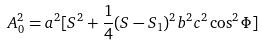<formula> <loc_0><loc_0><loc_500><loc_500>A _ { 0 } ^ { 2 } = a ^ { 2 } [ S ^ { 2 } + \frac { 1 } { 4 } ( S - S _ { 1 } ) ^ { 2 } b ^ { 2 } c ^ { 2 } \cos ^ { 2 } \Phi ]</formula> 